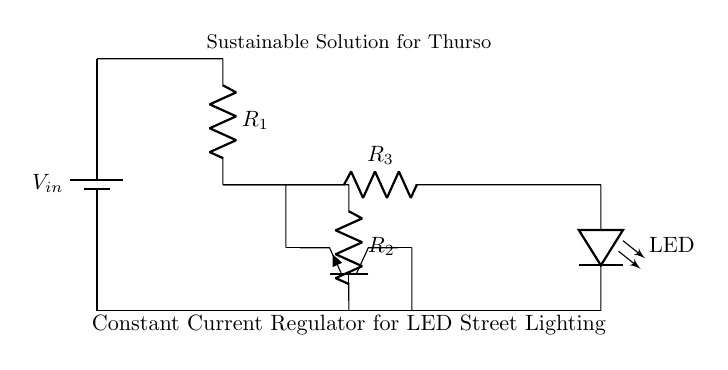What is the input voltage of the circuit? The input voltage is labeled as V_in at the battery, which directly indicates the voltage supplied to the circuit.
Answer: V_in How many resistors are in the circuit? The circuit includes three resistors labeled as R1, R2, and R3. The visual representation shows three distinct resistor symbols.
Answer: Three Where is the LED located in the circuit? The LED is located at the rightmost part of the circuit diagram, where it connects the circuit loop, specifically in the branch with R3.
Answer: Rightmost What type of transistors is used in this circuit? The circuit diagram features a Tnpn transistor, indicated by the specific labeling on the diagram. This signifies the type of transistor present.
Answer: Npn What is the primary function of this circuit? The main function of the circuit is to regulate the current, ensuring a constant output current for the LED street lighting, as indicated in the circuit's title.
Answer: Constant current regulation How do the resistors relate to the LED operation? The resistors in the circuit limit the current flowing through the LED, which prevents damage and maintains consistent brightness, showing their integral role in the operation.
Answer: Current limiting Why is a constant current regulator used for LED street lighting? A constant current regulator is essential because LEDs require a specific current for optimal performance, ensuring they operate efficiently and have a longer lifespan when powered correctly.
Answer: Efficiency and lifespan 